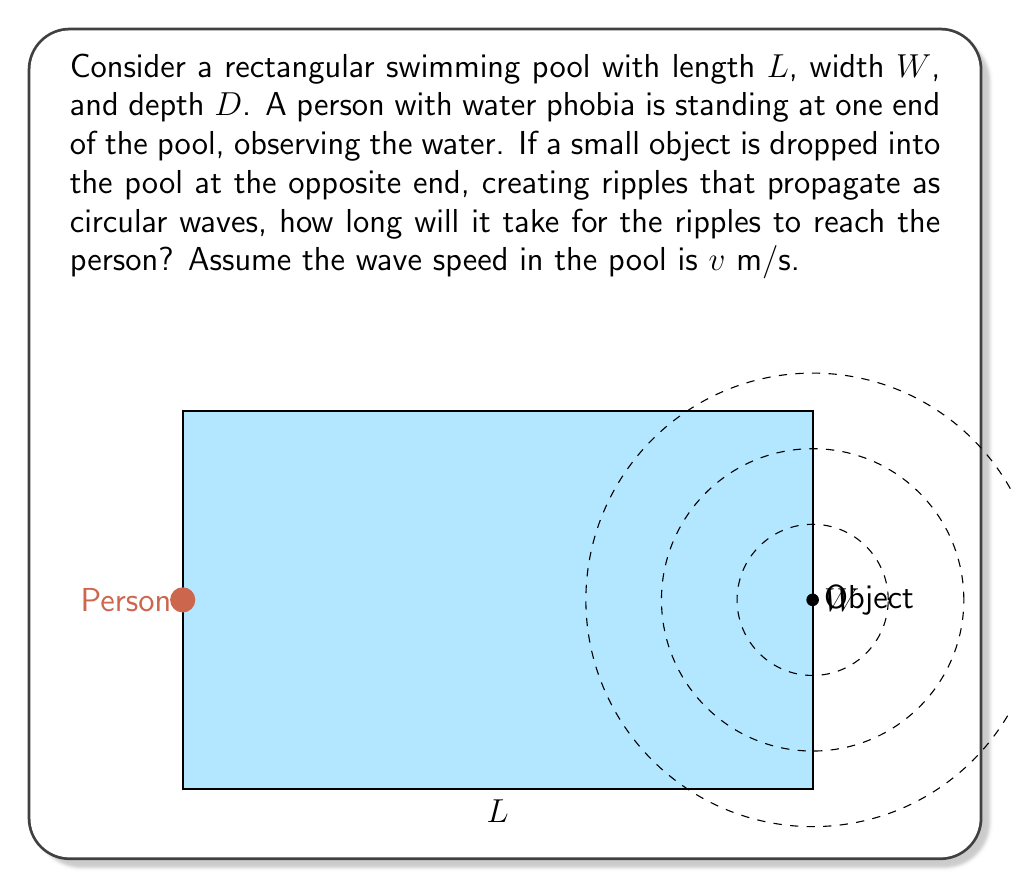Provide a solution to this math problem. To solve this problem, we need to follow these steps:

1) First, we need to understand that the ripples will travel the shortest distance from the point where the object is dropped to the person. This shortest distance is a straight line across the diagonal of the pool.

2) We can calculate this distance using the Pythagorean theorem. If we consider the length of the pool as one side of a right triangle and the width as another, the diagonal will be the hypotenuse.

3) The distance (d) the ripples need to travel is:

   $$d = \sqrt{L^2 + W^2}$$

4) Now, we can use the basic equation relating distance, speed, and time:

   $$\text{Distance} = \text{Speed} \times \text{Time}$$

   Or in symbols: $d = v \times t$

5) Rearranging this equation to solve for time:

   $$t = \frac{d}{v}$$

6) Substituting our expression for d:

   $$t = \frac{\sqrt{L^2 + W^2}}{v}$$

This gives us the time it takes for the ripples to reach the person at the other end of the pool.
Answer: $t = \frac{\sqrt{L^2 + W^2}}{v}$ seconds 